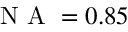Convert formula to latex. <formula><loc_0><loc_0><loc_500><loc_500>N A = 0 . 8 5</formula> 